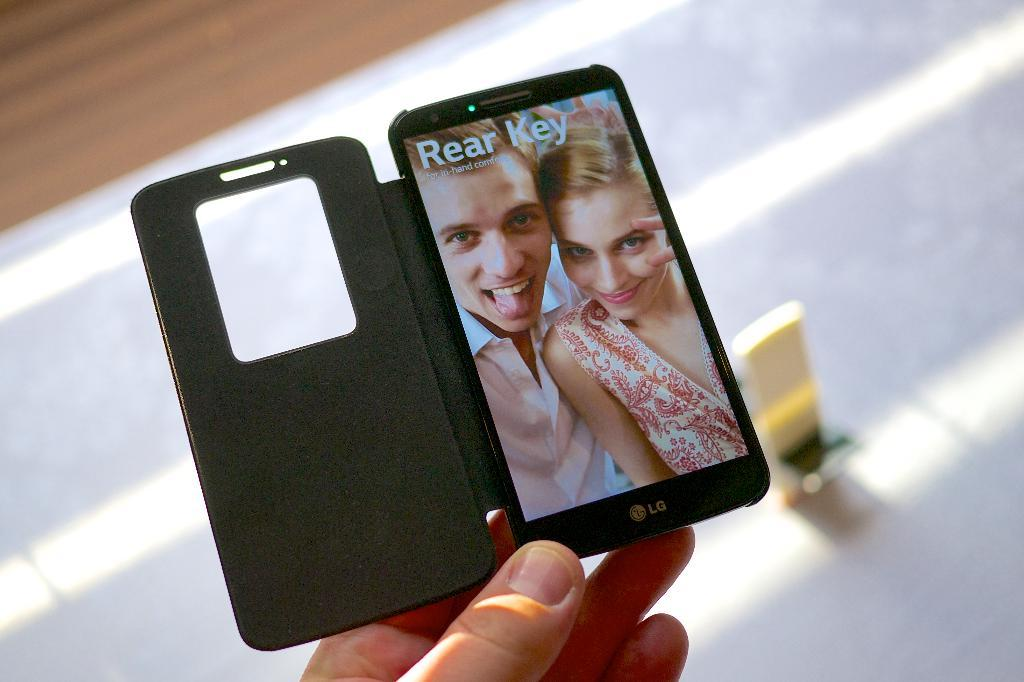What can be seen in the image? There is a person's hand in the image. What is the hand holding? The hand is holding a mobile phone. Is there a volcano erupting in the background of the image? No, there is no volcano or any background visible in the image; it only shows a person's hand holding a mobile phone. 